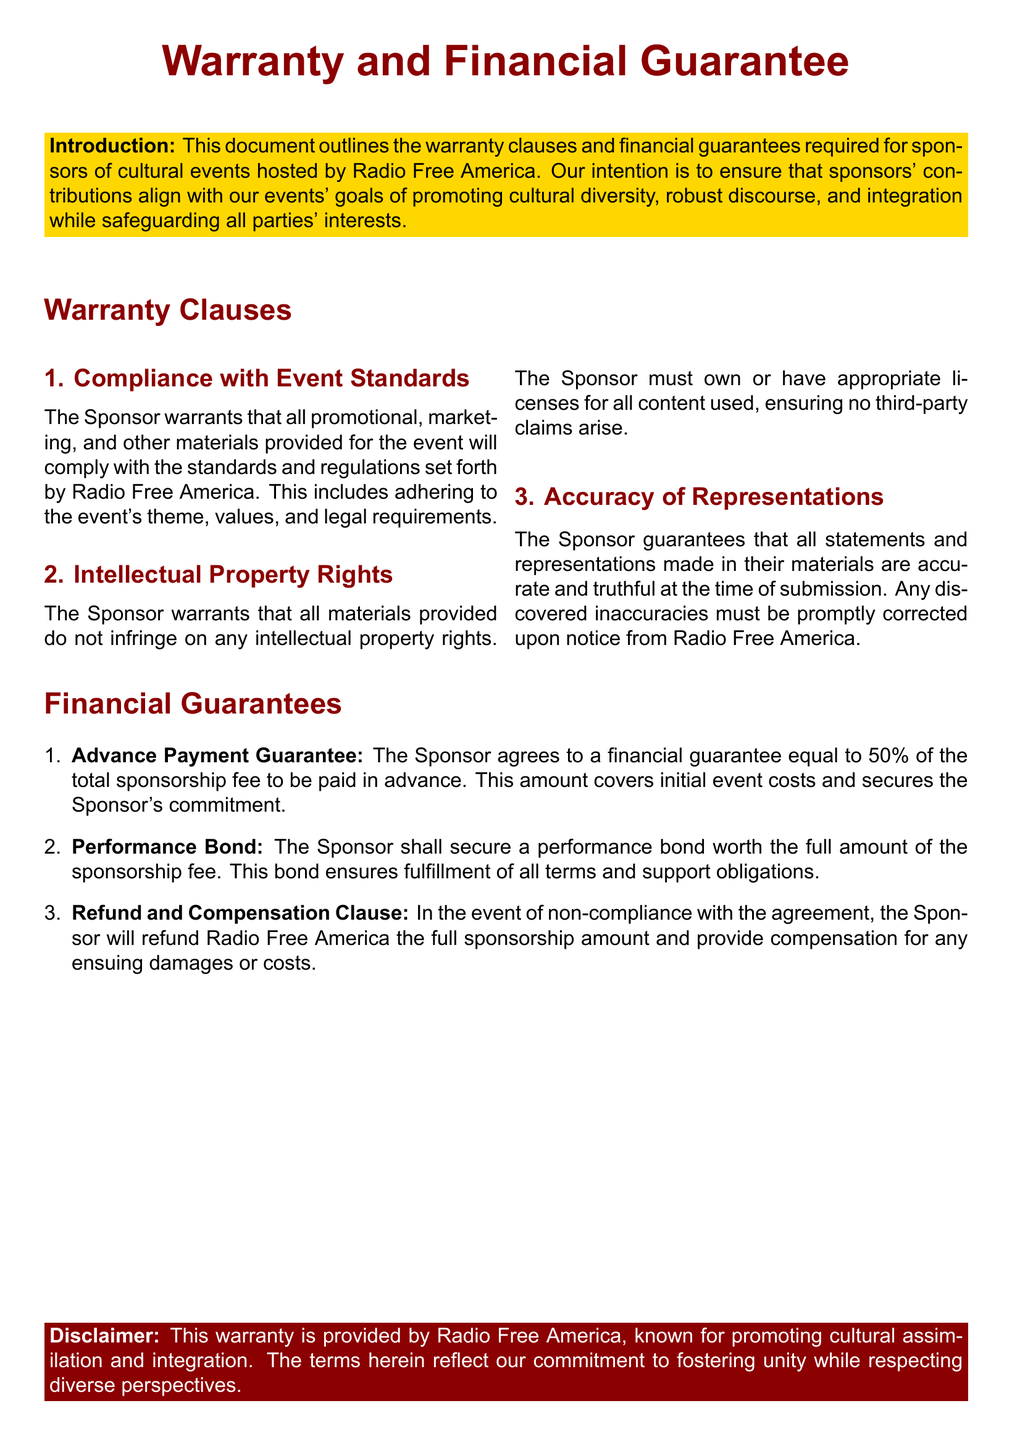What is the main title of the document? The main title reflects the primary focus of the document, which is stated prominently at the beginning.
Answer: Warranty and Financial Guarantee What percentage of the total sponsorship fee must be paid in advance? The document specifies the advance payment as a percentage to ensure financial commitment from the sponsors.
Answer: 50% What must the sponsor provide to ensure compliance? The document outlines requirements for sponsors, specifically focusing on the adherence to standards and regulations.
Answer: Promotional, marketing, and other materials What is required to secure the performance bond? The performance bond is a crucial financial aspect outlined to ensure the fulfillment of sponsorship obligations.
Answer: Full amount of the sponsorship fee What happens in the event of non-compliance? The document specifies the consequences of failing to adhere to the agreement, including refund requirements.
Answer: Refund the full sponsorship amount What is the purpose of the warranty clauses? The warranty clauses serve to protect the interests of all parties involved in the cultural event sponsorship agreement.
Answer: Safeguarding all parties' interests Which entity issues the warranty? The document clearly states the organization associated with the warranty, reflecting its mission and values.
Answer: Radio Free America What does the disclaimer emphasize? The disclaimer serves to clarify the organization's stance and objectives regarding cultural initiatives.
Answer: Fostering unity while respecting diverse perspectives 